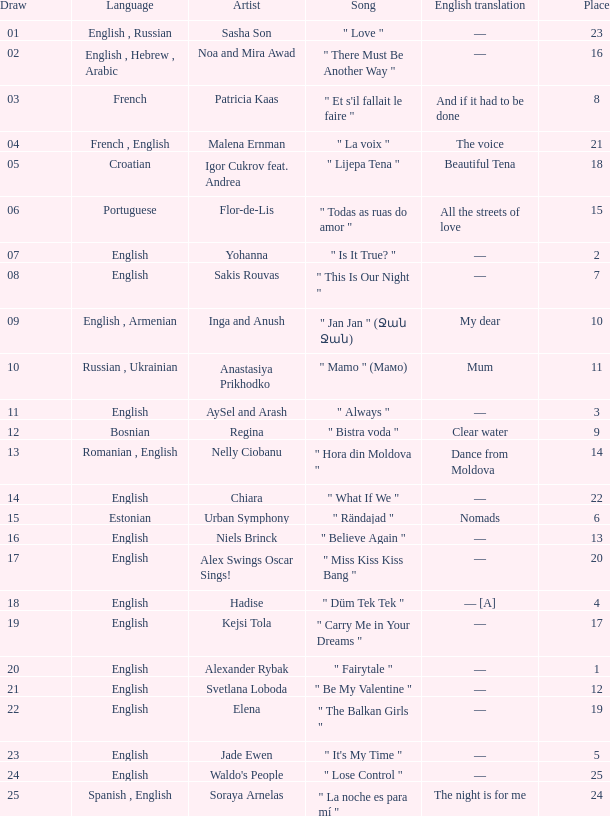What was the average place for the song that had 69 points and a draw smaller than 13? None. 